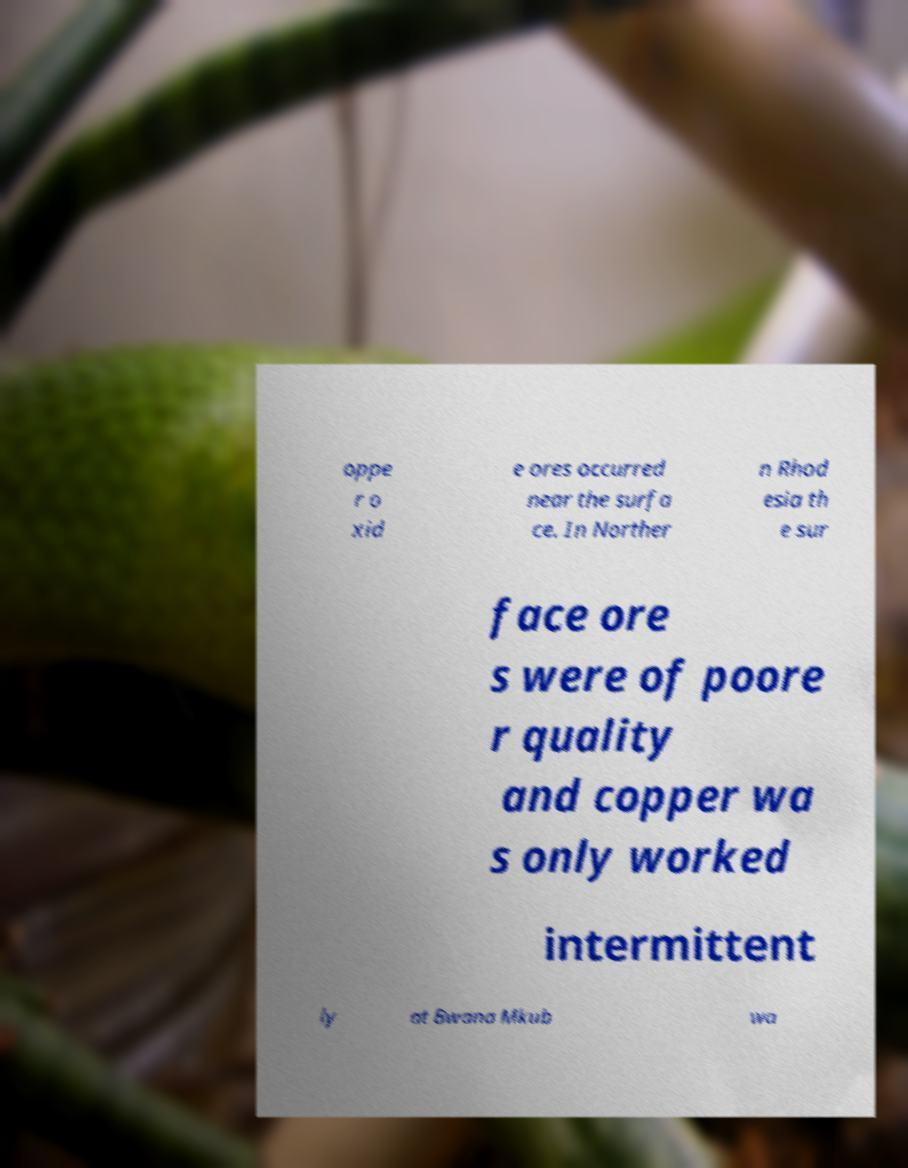There's text embedded in this image that I need extracted. Can you transcribe it verbatim? oppe r o xid e ores occurred near the surfa ce. In Norther n Rhod esia th e sur face ore s were of poore r quality and copper wa s only worked intermittent ly at Bwana Mkub wa 